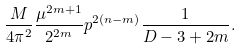<formula> <loc_0><loc_0><loc_500><loc_500>\frac { M } { 4 \pi ^ { 2 } } \frac { \mu ^ { 2 m + 1 } } { 2 ^ { 2 m } } p ^ { 2 ( n - m ) } \frac { 1 } { D - 3 + 2 m } .</formula> 